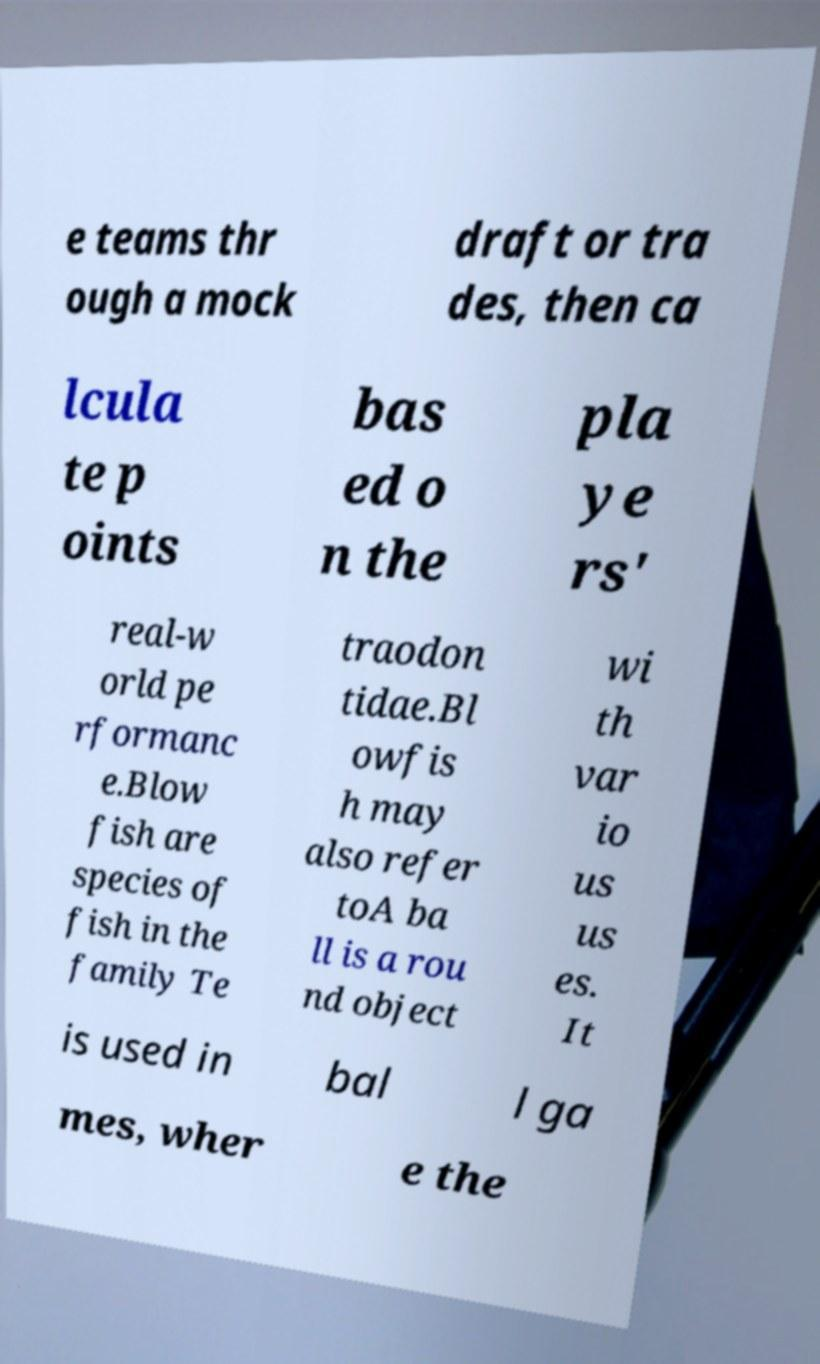There's text embedded in this image that I need extracted. Can you transcribe it verbatim? e teams thr ough a mock draft or tra des, then ca lcula te p oints bas ed o n the pla ye rs' real-w orld pe rformanc e.Blow fish are species of fish in the family Te traodon tidae.Bl owfis h may also refer toA ba ll is a rou nd object wi th var io us us es. It is used in bal l ga mes, wher e the 